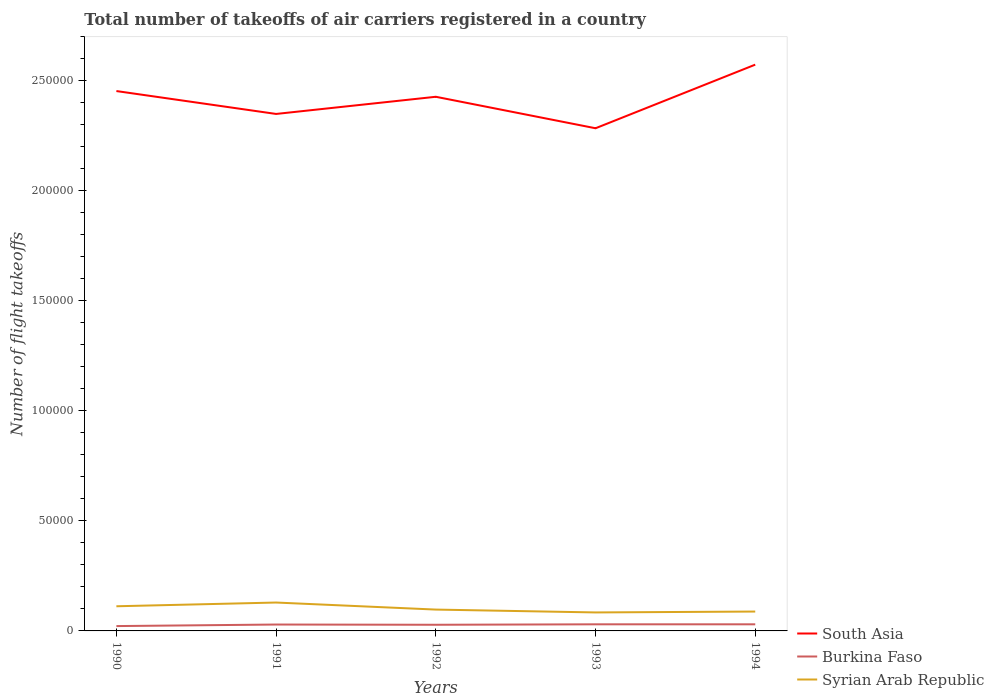How many different coloured lines are there?
Provide a succinct answer. 3. Across all years, what is the maximum total number of flight takeoffs in Burkina Faso?
Ensure brevity in your answer.  2200. What is the total total number of flight takeoffs in Syrian Arab Republic in the graph?
Keep it short and to the point. -400. What is the difference between the highest and the second highest total number of flight takeoffs in Syrian Arab Republic?
Provide a succinct answer. 4500. Is the total number of flight takeoffs in South Asia strictly greater than the total number of flight takeoffs in Burkina Faso over the years?
Provide a succinct answer. No. How many lines are there?
Make the answer very short. 3. What is the difference between two consecutive major ticks on the Y-axis?
Give a very brief answer. 5.00e+04. Are the values on the major ticks of Y-axis written in scientific E-notation?
Provide a succinct answer. No. Does the graph contain grids?
Provide a succinct answer. No. Where does the legend appear in the graph?
Provide a succinct answer. Bottom right. How are the legend labels stacked?
Keep it short and to the point. Vertical. What is the title of the graph?
Offer a very short reply. Total number of takeoffs of air carriers registered in a country. Does "Liechtenstein" appear as one of the legend labels in the graph?
Ensure brevity in your answer.  No. What is the label or title of the Y-axis?
Provide a short and direct response. Number of flight takeoffs. What is the Number of flight takeoffs in South Asia in 1990?
Offer a very short reply. 2.45e+05. What is the Number of flight takeoffs in Burkina Faso in 1990?
Provide a succinct answer. 2200. What is the Number of flight takeoffs in Syrian Arab Republic in 1990?
Make the answer very short. 1.12e+04. What is the Number of flight takeoffs of South Asia in 1991?
Provide a short and direct response. 2.35e+05. What is the Number of flight takeoffs in Burkina Faso in 1991?
Your answer should be very brief. 2900. What is the Number of flight takeoffs in Syrian Arab Republic in 1991?
Your answer should be compact. 1.29e+04. What is the Number of flight takeoffs of South Asia in 1992?
Make the answer very short. 2.43e+05. What is the Number of flight takeoffs in Burkina Faso in 1992?
Give a very brief answer. 2800. What is the Number of flight takeoffs in Syrian Arab Republic in 1992?
Provide a short and direct response. 9700. What is the Number of flight takeoffs in South Asia in 1993?
Give a very brief answer. 2.28e+05. What is the Number of flight takeoffs in Burkina Faso in 1993?
Provide a succinct answer. 3000. What is the Number of flight takeoffs in Syrian Arab Republic in 1993?
Make the answer very short. 8400. What is the Number of flight takeoffs in South Asia in 1994?
Your answer should be very brief. 2.57e+05. What is the Number of flight takeoffs of Burkina Faso in 1994?
Provide a short and direct response. 3000. What is the Number of flight takeoffs in Syrian Arab Republic in 1994?
Provide a short and direct response. 8800. Across all years, what is the maximum Number of flight takeoffs in South Asia?
Provide a succinct answer. 2.57e+05. Across all years, what is the maximum Number of flight takeoffs in Burkina Faso?
Give a very brief answer. 3000. Across all years, what is the maximum Number of flight takeoffs in Syrian Arab Republic?
Offer a terse response. 1.29e+04. Across all years, what is the minimum Number of flight takeoffs of South Asia?
Offer a terse response. 2.28e+05. Across all years, what is the minimum Number of flight takeoffs in Burkina Faso?
Make the answer very short. 2200. Across all years, what is the minimum Number of flight takeoffs of Syrian Arab Republic?
Offer a very short reply. 8400. What is the total Number of flight takeoffs of South Asia in the graph?
Give a very brief answer. 1.21e+06. What is the total Number of flight takeoffs in Burkina Faso in the graph?
Give a very brief answer. 1.39e+04. What is the total Number of flight takeoffs in Syrian Arab Republic in the graph?
Make the answer very short. 5.10e+04. What is the difference between the Number of flight takeoffs in South Asia in 1990 and that in 1991?
Your response must be concise. 1.04e+04. What is the difference between the Number of flight takeoffs in Burkina Faso in 1990 and that in 1991?
Offer a very short reply. -700. What is the difference between the Number of flight takeoffs in Syrian Arab Republic in 1990 and that in 1991?
Your response must be concise. -1700. What is the difference between the Number of flight takeoffs in South Asia in 1990 and that in 1992?
Offer a very short reply. 2600. What is the difference between the Number of flight takeoffs of Burkina Faso in 1990 and that in 1992?
Your response must be concise. -600. What is the difference between the Number of flight takeoffs of Syrian Arab Republic in 1990 and that in 1992?
Give a very brief answer. 1500. What is the difference between the Number of flight takeoffs in South Asia in 1990 and that in 1993?
Ensure brevity in your answer.  1.69e+04. What is the difference between the Number of flight takeoffs in Burkina Faso in 1990 and that in 1993?
Keep it short and to the point. -800. What is the difference between the Number of flight takeoffs of Syrian Arab Republic in 1990 and that in 1993?
Provide a succinct answer. 2800. What is the difference between the Number of flight takeoffs of South Asia in 1990 and that in 1994?
Provide a short and direct response. -1.20e+04. What is the difference between the Number of flight takeoffs in Burkina Faso in 1990 and that in 1994?
Your answer should be compact. -800. What is the difference between the Number of flight takeoffs in Syrian Arab Republic in 1990 and that in 1994?
Offer a very short reply. 2400. What is the difference between the Number of flight takeoffs in South Asia in 1991 and that in 1992?
Your response must be concise. -7800. What is the difference between the Number of flight takeoffs of Burkina Faso in 1991 and that in 1992?
Make the answer very short. 100. What is the difference between the Number of flight takeoffs in Syrian Arab Republic in 1991 and that in 1992?
Offer a very short reply. 3200. What is the difference between the Number of flight takeoffs of South Asia in 1991 and that in 1993?
Your answer should be very brief. 6500. What is the difference between the Number of flight takeoffs in Burkina Faso in 1991 and that in 1993?
Keep it short and to the point. -100. What is the difference between the Number of flight takeoffs in Syrian Arab Republic in 1991 and that in 1993?
Offer a terse response. 4500. What is the difference between the Number of flight takeoffs of South Asia in 1991 and that in 1994?
Give a very brief answer. -2.24e+04. What is the difference between the Number of flight takeoffs in Burkina Faso in 1991 and that in 1994?
Make the answer very short. -100. What is the difference between the Number of flight takeoffs in Syrian Arab Republic in 1991 and that in 1994?
Provide a succinct answer. 4100. What is the difference between the Number of flight takeoffs in South Asia in 1992 and that in 1993?
Your answer should be very brief. 1.43e+04. What is the difference between the Number of flight takeoffs in Burkina Faso in 1992 and that in 1993?
Your answer should be very brief. -200. What is the difference between the Number of flight takeoffs in Syrian Arab Republic in 1992 and that in 1993?
Ensure brevity in your answer.  1300. What is the difference between the Number of flight takeoffs of South Asia in 1992 and that in 1994?
Give a very brief answer. -1.46e+04. What is the difference between the Number of flight takeoffs in Burkina Faso in 1992 and that in 1994?
Offer a terse response. -200. What is the difference between the Number of flight takeoffs in Syrian Arab Republic in 1992 and that in 1994?
Your response must be concise. 900. What is the difference between the Number of flight takeoffs of South Asia in 1993 and that in 1994?
Make the answer very short. -2.89e+04. What is the difference between the Number of flight takeoffs of Burkina Faso in 1993 and that in 1994?
Your response must be concise. 0. What is the difference between the Number of flight takeoffs of Syrian Arab Republic in 1993 and that in 1994?
Provide a succinct answer. -400. What is the difference between the Number of flight takeoffs in South Asia in 1990 and the Number of flight takeoffs in Burkina Faso in 1991?
Give a very brief answer. 2.42e+05. What is the difference between the Number of flight takeoffs of South Asia in 1990 and the Number of flight takeoffs of Syrian Arab Republic in 1991?
Your answer should be compact. 2.32e+05. What is the difference between the Number of flight takeoffs in Burkina Faso in 1990 and the Number of flight takeoffs in Syrian Arab Republic in 1991?
Give a very brief answer. -1.07e+04. What is the difference between the Number of flight takeoffs of South Asia in 1990 and the Number of flight takeoffs of Burkina Faso in 1992?
Keep it short and to the point. 2.42e+05. What is the difference between the Number of flight takeoffs of South Asia in 1990 and the Number of flight takeoffs of Syrian Arab Republic in 1992?
Your answer should be compact. 2.36e+05. What is the difference between the Number of flight takeoffs in Burkina Faso in 1990 and the Number of flight takeoffs in Syrian Arab Republic in 1992?
Offer a terse response. -7500. What is the difference between the Number of flight takeoffs of South Asia in 1990 and the Number of flight takeoffs of Burkina Faso in 1993?
Ensure brevity in your answer.  2.42e+05. What is the difference between the Number of flight takeoffs of South Asia in 1990 and the Number of flight takeoffs of Syrian Arab Republic in 1993?
Your response must be concise. 2.37e+05. What is the difference between the Number of flight takeoffs in Burkina Faso in 1990 and the Number of flight takeoffs in Syrian Arab Republic in 1993?
Offer a terse response. -6200. What is the difference between the Number of flight takeoffs in South Asia in 1990 and the Number of flight takeoffs in Burkina Faso in 1994?
Ensure brevity in your answer.  2.42e+05. What is the difference between the Number of flight takeoffs of South Asia in 1990 and the Number of flight takeoffs of Syrian Arab Republic in 1994?
Your answer should be compact. 2.36e+05. What is the difference between the Number of flight takeoffs of Burkina Faso in 1990 and the Number of flight takeoffs of Syrian Arab Republic in 1994?
Your answer should be very brief. -6600. What is the difference between the Number of flight takeoffs of South Asia in 1991 and the Number of flight takeoffs of Burkina Faso in 1992?
Offer a terse response. 2.32e+05. What is the difference between the Number of flight takeoffs in South Asia in 1991 and the Number of flight takeoffs in Syrian Arab Republic in 1992?
Keep it short and to the point. 2.25e+05. What is the difference between the Number of flight takeoffs in Burkina Faso in 1991 and the Number of flight takeoffs in Syrian Arab Republic in 1992?
Provide a short and direct response. -6800. What is the difference between the Number of flight takeoffs of South Asia in 1991 and the Number of flight takeoffs of Burkina Faso in 1993?
Your answer should be very brief. 2.32e+05. What is the difference between the Number of flight takeoffs of South Asia in 1991 and the Number of flight takeoffs of Syrian Arab Republic in 1993?
Your answer should be very brief. 2.26e+05. What is the difference between the Number of flight takeoffs of Burkina Faso in 1991 and the Number of flight takeoffs of Syrian Arab Republic in 1993?
Keep it short and to the point. -5500. What is the difference between the Number of flight takeoffs in South Asia in 1991 and the Number of flight takeoffs in Burkina Faso in 1994?
Ensure brevity in your answer.  2.32e+05. What is the difference between the Number of flight takeoffs of South Asia in 1991 and the Number of flight takeoffs of Syrian Arab Republic in 1994?
Your response must be concise. 2.26e+05. What is the difference between the Number of flight takeoffs of Burkina Faso in 1991 and the Number of flight takeoffs of Syrian Arab Republic in 1994?
Your response must be concise. -5900. What is the difference between the Number of flight takeoffs in South Asia in 1992 and the Number of flight takeoffs in Burkina Faso in 1993?
Offer a very short reply. 2.40e+05. What is the difference between the Number of flight takeoffs of South Asia in 1992 and the Number of flight takeoffs of Syrian Arab Republic in 1993?
Ensure brevity in your answer.  2.34e+05. What is the difference between the Number of flight takeoffs in Burkina Faso in 1992 and the Number of flight takeoffs in Syrian Arab Republic in 1993?
Offer a terse response. -5600. What is the difference between the Number of flight takeoffs in South Asia in 1992 and the Number of flight takeoffs in Burkina Faso in 1994?
Offer a terse response. 2.40e+05. What is the difference between the Number of flight takeoffs in South Asia in 1992 and the Number of flight takeoffs in Syrian Arab Republic in 1994?
Make the answer very short. 2.34e+05. What is the difference between the Number of flight takeoffs of Burkina Faso in 1992 and the Number of flight takeoffs of Syrian Arab Republic in 1994?
Give a very brief answer. -6000. What is the difference between the Number of flight takeoffs in South Asia in 1993 and the Number of flight takeoffs in Burkina Faso in 1994?
Ensure brevity in your answer.  2.25e+05. What is the difference between the Number of flight takeoffs in South Asia in 1993 and the Number of flight takeoffs in Syrian Arab Republic in 1994?
Provide a short and direct response. 2.20e+05. What is the difference between the Number of flight takeoffs in Burkina Faso in 1993 and the Number of flight takeoffs in Syrian Arab Republic in 1994?
Ensure brevity in your answer.  -5800. What is the average Number of flight takeoffs in South Asia per year?
Offer a very short reply. 2.42e+05. What is the average Number of flight takeoffs of Burkina Faso per year?
Offer a very short reply. 2780. What is the average Number of flight takeoffs in Syrian Arab Republic per year?
Offer a terse response. 1.02e+04. In the year 1990, what is the difference between the Number of flight takeoffs in South Asia and Number of flight takeoffs in Burkina Faso?
Keep it short and to the point. 2.43e+05. In the year 1990, what is the difference between the Number of flight takeoffs of South Asia and Number of flight takeoffs of Syrian Arab Republic?
Ensure brevity in your answer.  2.34e+05. In the year 1990, what is the difference between the Number of flight takeoffs in Burkina Faso and Number of flight takeoffs in Syrian Arab Republic?
Your response must be concise. -9000. In the year 1991, what is the difference between the Number of flight takeoffs of South Asia and Number of flight takeoffs of Burkina Faso?
Ensure brevity in your answer.  2.32e+05. In the year 1991, what is the difference between the Number of flight takeoffs of South Asia and Number of flight takeoffs of Syrian Arab Republic?
Give a very brief answer. 2.22e+05. In the year 1991, what is the difference between the Number of flight takeoffs in Burkina Faso and Number of flight takeoffs in Syrian Arab Republic?
Keep it short and to the point. -10000. In the year 1992, what is the difference between the Number of flight takeoffs in South Asia and Number of flight takeoffs in Burkina Faso?
Your answer should be very brief. 2.40e+05. In the year 1992, what is the difference between the Number of flight takeoffs of South Asia and Number of flight takeoffs of Syrian Arab Republic?
Your answer should be compact. 2.33e+05. In the year 1992, what is the difference between the Number of flight takeoffs in Burkina Faso and Number of flight takeoffs in Syrian Arab Republic?
Make the answer very short. -6900. In the year 1993, what is the difference between the Number of flight takeoffs in South Asia and Number of flight takeoffs in Burkina Faso?
Keep it short and to the point. 2.25e+05. In the year 1993, what is the difference between the Number of flight takeoffs in Burkina Faso and Number of flight takeoffs in Syrian Arab Republic?
Provide a succinct answer. -5400. In the year 1994, what is the difference between the Number of flight takeoffs in South Asia and Number of flight takeoffs in Burkina Faso?
Provide a short and direct response. 2.54e+05. In the year 1994, what is the difference between the Number of flight takeoffs of South Asia and Number of flight takeoffs of Syrian Arab Republic?
Offer a terse response. 2.48e+05. In the year 1994, what is the difference between the Number of flight takeoffs of Burkina Faso and Number of flight takeoffs of Syrian Arab Republic?
Ensure brevity in your answer.  -5800. What is the ratio of the Number of flight takeoffs in South Asia in 1990 to that in 1991?
Provide a short and direct response. 1.04. What is the ratio of the Number of flight takeoffs in Burkina Faso in 1990 to that in 1991?
Provide a short and direct response. 0.76. What is the ratio of the Number of flight takeoffs of Syrian Arab Republic in 1990 to that in 1991?
Provide a succinct answer. 0.87. What is the ratio of the Number of flight takeoffs of South Asia in 1990 to that in 1992?
Ensure brevity in your answer.  1.01. What is the ratio of the Number of flight takeoffs in Burkina Faso in 1990 to that in 1992?
Keep it short and to the point. 0.79. What is the ratio of the Number of flight takeoffs in Syrian Arab Republic in 1990 to that in 1992?
Your answer should be compact. 1.15. What is the ratio of the Number of flight takeoffs in South Asia in 1990 to that in 1993?
Provide a short and direct response. 1.07. What is the ratio of the Number of flight takeoffs in Burkina Faso in 1990 to that in 1993?
Provide a succinct answer. 0.73. What is the ratio of the Number of flight takeoffs in South Asia in 1990 to that in 1994?
Your answer should be very brief. 0.95. What is the ratio of the Number of flight takeoffs of Burkina Faso in 1990 to that in 1994?
Your response must be concise. 0.73. What is the ratio of the Number of flight takeoffs in Syrian Arab Republic in 1990 to that in 1994?
Your answer should be very brief. 1.27. What is the ratio of the Number of flight takeoffs in South Asia in 1991 to that in 1992?
Offer a very short reply. 0.97. What is the ratio of the Number of flight takeoffs of Burkina Faso in 1991 to that in 1992?
Your answer should be very brief. 1.04. What is the ratio of the Number of flight takeoffs in Syrian Arab Republic in 1991 to that in 1992?
Offer a terse response. 1.33. What is the ratio of the Number of flight takeoffs in South Asia in 1991 to that in 1993?
Your answer should be compact. 1.03. What is the ratio of the Number of flight takeoffs of Burkina Faso in 1991 to that in 1993?
Your answer should be compact. 0.97. What is the ratio of the Number of flight takeoffs of Syrian Arab Republic in 1991 to that in 1993?
Ensure brevity in your answer.  1.54. What is the ratio of the Number of flight takeoffs of South Asia in 1991 to that in 1994?
Offer a terse response. 0.91. What is the ratio of the Number of flight takeoffs in Burkina Faso in 1991 to that in 1994?
Your answer should be compact. 0.97. What is the ratio of the Number of flight takeoffs of Syrian Arab Republic in 1991 to that in 1994?
Offer a very short reply. 1.47. What is the ratio of the Number of flight takeoffs in South Asia in 1992 to that in 1993?
Your response must be concise. 1.06. What is the ratio of the Number of flight takeoffs of Syrian Arab Republic in 1992 to that in 1993?
Make the answer very short. 1.15. What is the ratio of the Number of flight takeoffs of South Asia in 1992 to that in 1994?
Keep it short and to the point. 0.94. What is the ratio of the Number of flight takeoffs in Burkina Faso in 1992 to that in 1994?
Provide a succinct answer. 0.93. What is the ratio of the Number of flight takeoffs in Syrian Arab Republic in 1992 to that in 1994?
Keep it short and to the point. 1.1. What is the ratio of the Number of flight takeoffs in South Asia in 1993 to that in 1994?
Make the answer very short. 0.89. What is the ratio of the Number of flight takeoffs of Syrian Arab Republic in 1993 to that in 1994?
Make the answer very short. 0.95. What is the difference between the highest and the second highest Number of flight takeoffs in South Asia?
Offer a terse response. 1.20e+04. What is the difference between the highest and the second highest Number of flight takeoffs in Syrian Arab Republic?
Your answer should be compact. 1700. What is the difference between the highest and the lowest Number of flight takeoffs of South Asia?
Make the answer very short. 2.89e+04. What is the difference between the highest and the lowest Number of flight takeoffs in Burkina Faso?
Provide a succinct answer. 800. What is the difference between the highest and the lowest Number of flight takeoffs of Syrian Arab Republic?
Give a very brief answer. 4500. 